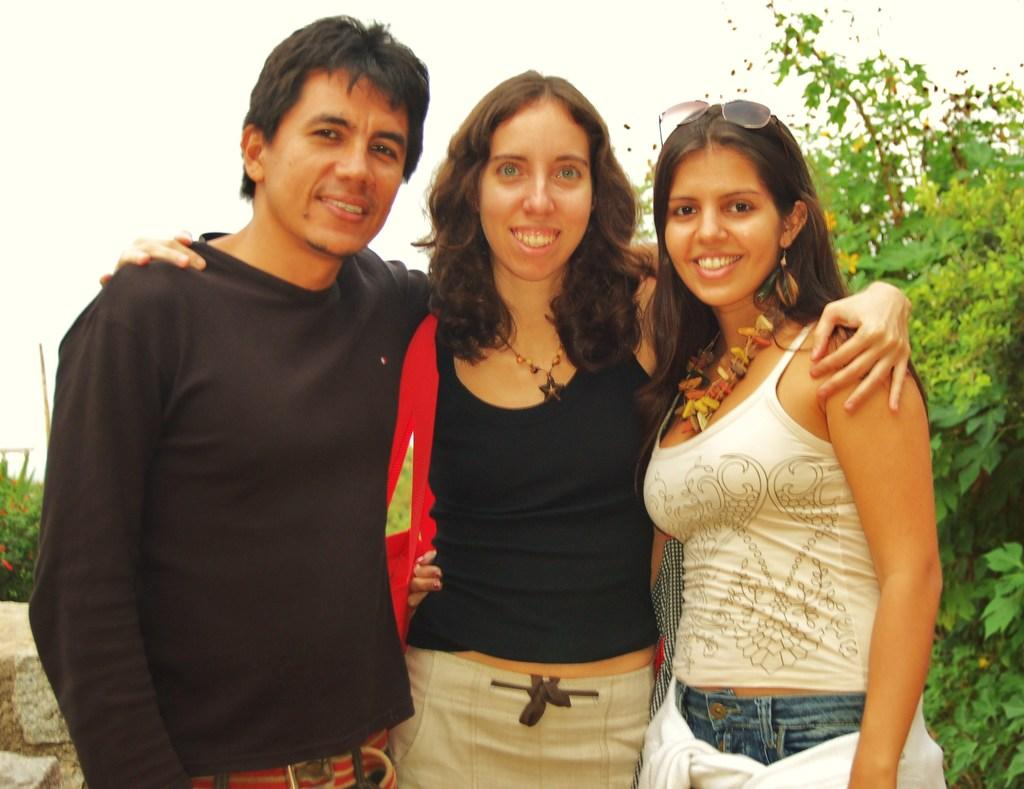How many people are present in the image? There are three people standing in the image. What can be seen in the background of the image? There are trees visible in the background of the image. What is the name of the club where the people are gathered in the image? There is no indication of a club or gathering in the image; it simply shows three people standing with trees in the background. 